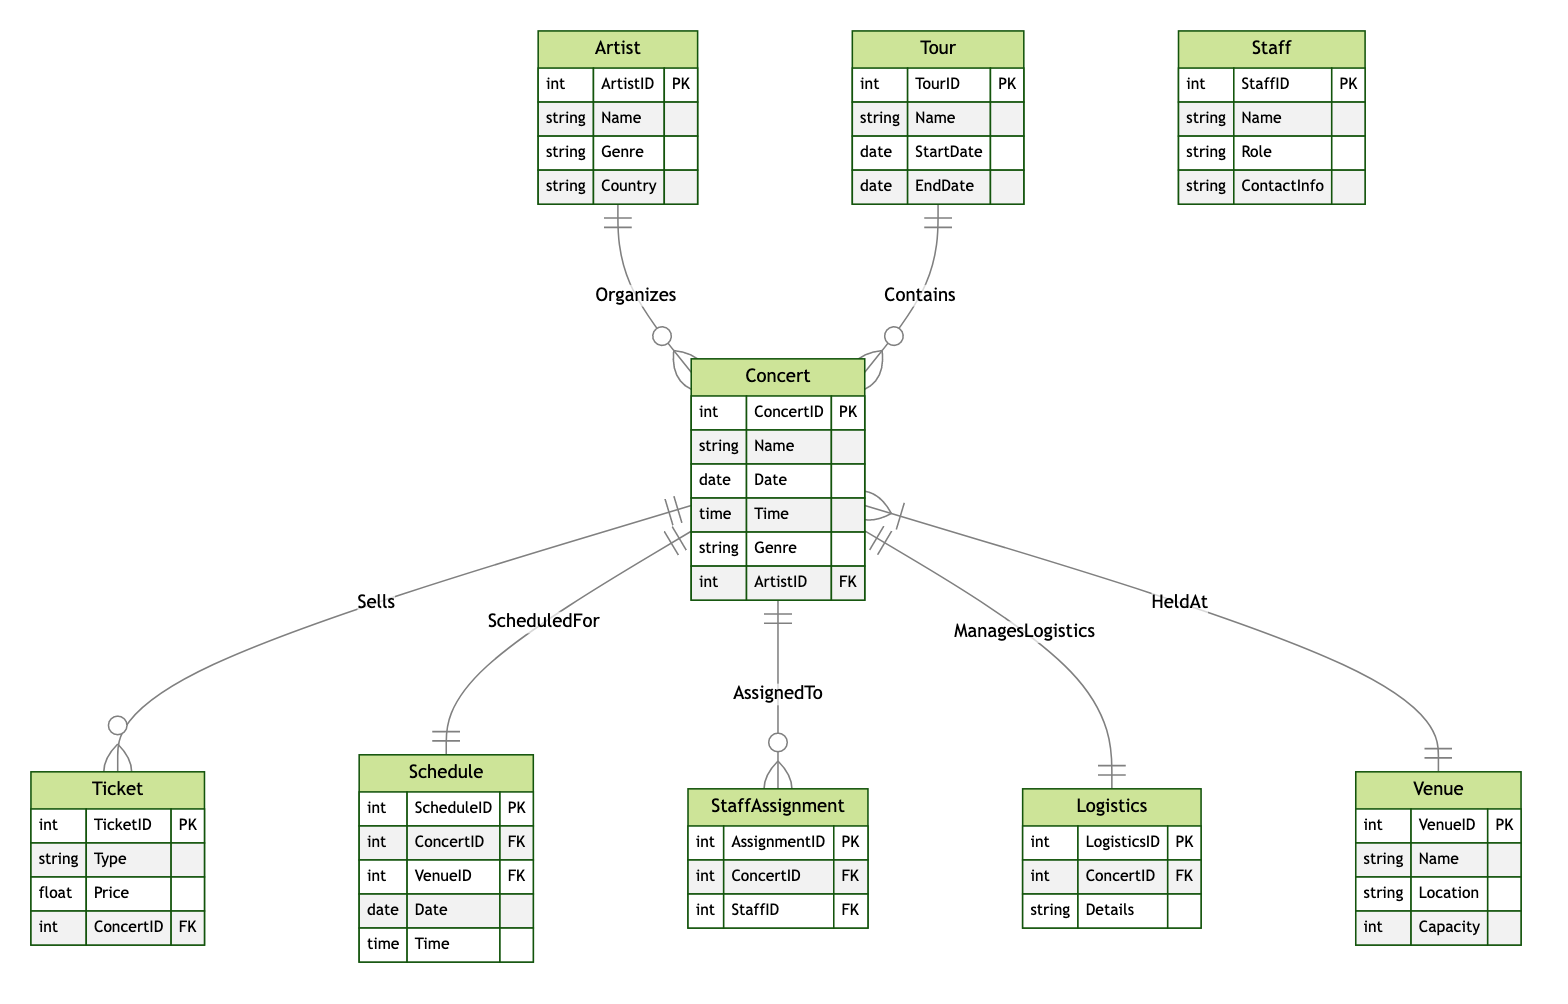What is the primary key of the Concert entity? The primary key of the Concert entity is specified as ConcertID, which uniquely identifies each concert in the system.
Answer: ConcertID How many entities are in the diagram? By counting the different types of entities listed in the diagram, we find there are nine entities: Concert, Tour, Venue, Ticket, Schedule, Staff, StaffAssignment, Logistics, and Artist.
Answer: Nine What type of relationship exists between Artist and Concert? The relationship between Artist and Concert is defined as "Organizes", indicating that an artist organizes one or more concerts.
Answer: Organizes Which entity manages logistics for the concerts? The entity responsible for managing logistics is Logistics, as indicated by the relationship "ManagesLogistics" connecting Concert and Logistics.
Answer: Logistics What does the Ticket entity sell? The Ticket entity is shown to sell tickets specifically for concerts as indicated by the relationship "Sells" where Concert and Ticket are connected.
Answer: Tickets What is the foreign key in the Ticket entity? The Ticket entity contains the foreign key ConcertID, which links it to the Concert entity to indicate which concert the ticket is associated with.
Answer: ConcertID How many Concerts can be scheduled within a Tour? A tour can contain multiple concerts, indicating a one-to-many relationship, thus allowing any number of concerts (potentially unlimited) as indicated by the relationship "Contains".
Answer: Many Which entities are involved in the ScheduledFor relationship? The ScheduledFor relationship involves both the Concert and Schedule entities, indicating that each concert has a corresponding schedule entry.
Answer: Concert and Schedule What is the role of Staff in the diagram? Staff in the diagram plays the role of assisting concerts, as indicated by the StaffAssignment entity which links staff members to specific concerts.
Answer: Assisting concerts 